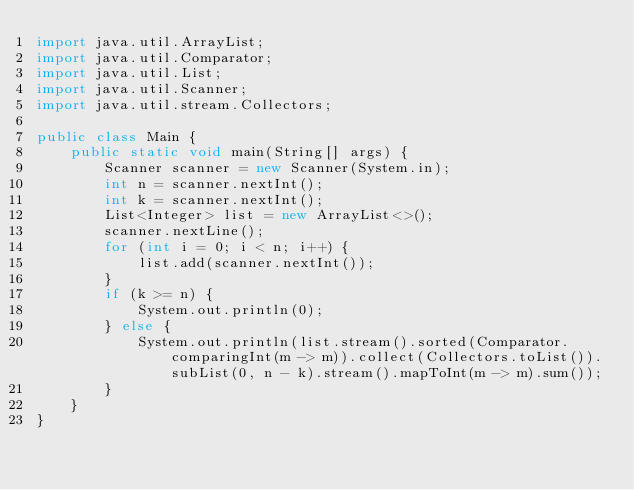Convert code to text. <code><loc_0><loc_0><loc_500><loc_500><_Java_>import java.util.ArrayList;
import java.util.Comparator;
import java.util.List;
import java.util.Scanner;
import java.util.stream.Collectors;

public class Main {
    public static void main(String[] args) {
        Scanner scanner = new Scanner(System.in);
        int n = scanner.nextInt();
        int k = scanner.nextInt();
        List<Integer> list = new ArrayList<>();
        scanner.nextLine();
        for (int i = 0; i < n; i++) {
            list.add(scanner.nextInt());
        }
        if (k >= n) {
            System.out.println(0);
        } else {
            System.out.println(list.stream().sorted(Comparator.comparingInt(m -> m)).collect(Collectors.toList()).subList(0, n - k).stream().mapToInt(m -> m).sum());
        }
    }
}
</code> 